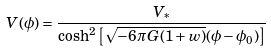Convert formula to latex. <formula><loc_0><loc_0><loc_500><loc_500>V ( \phi ) = \frac { V _ { * } } { \cosh ^ { 2 } \left [ \sqrt { - 6 \pi G ( 1 + w ) } ( \phi - \phi _ { 0 } ) \right ] }</formula> 